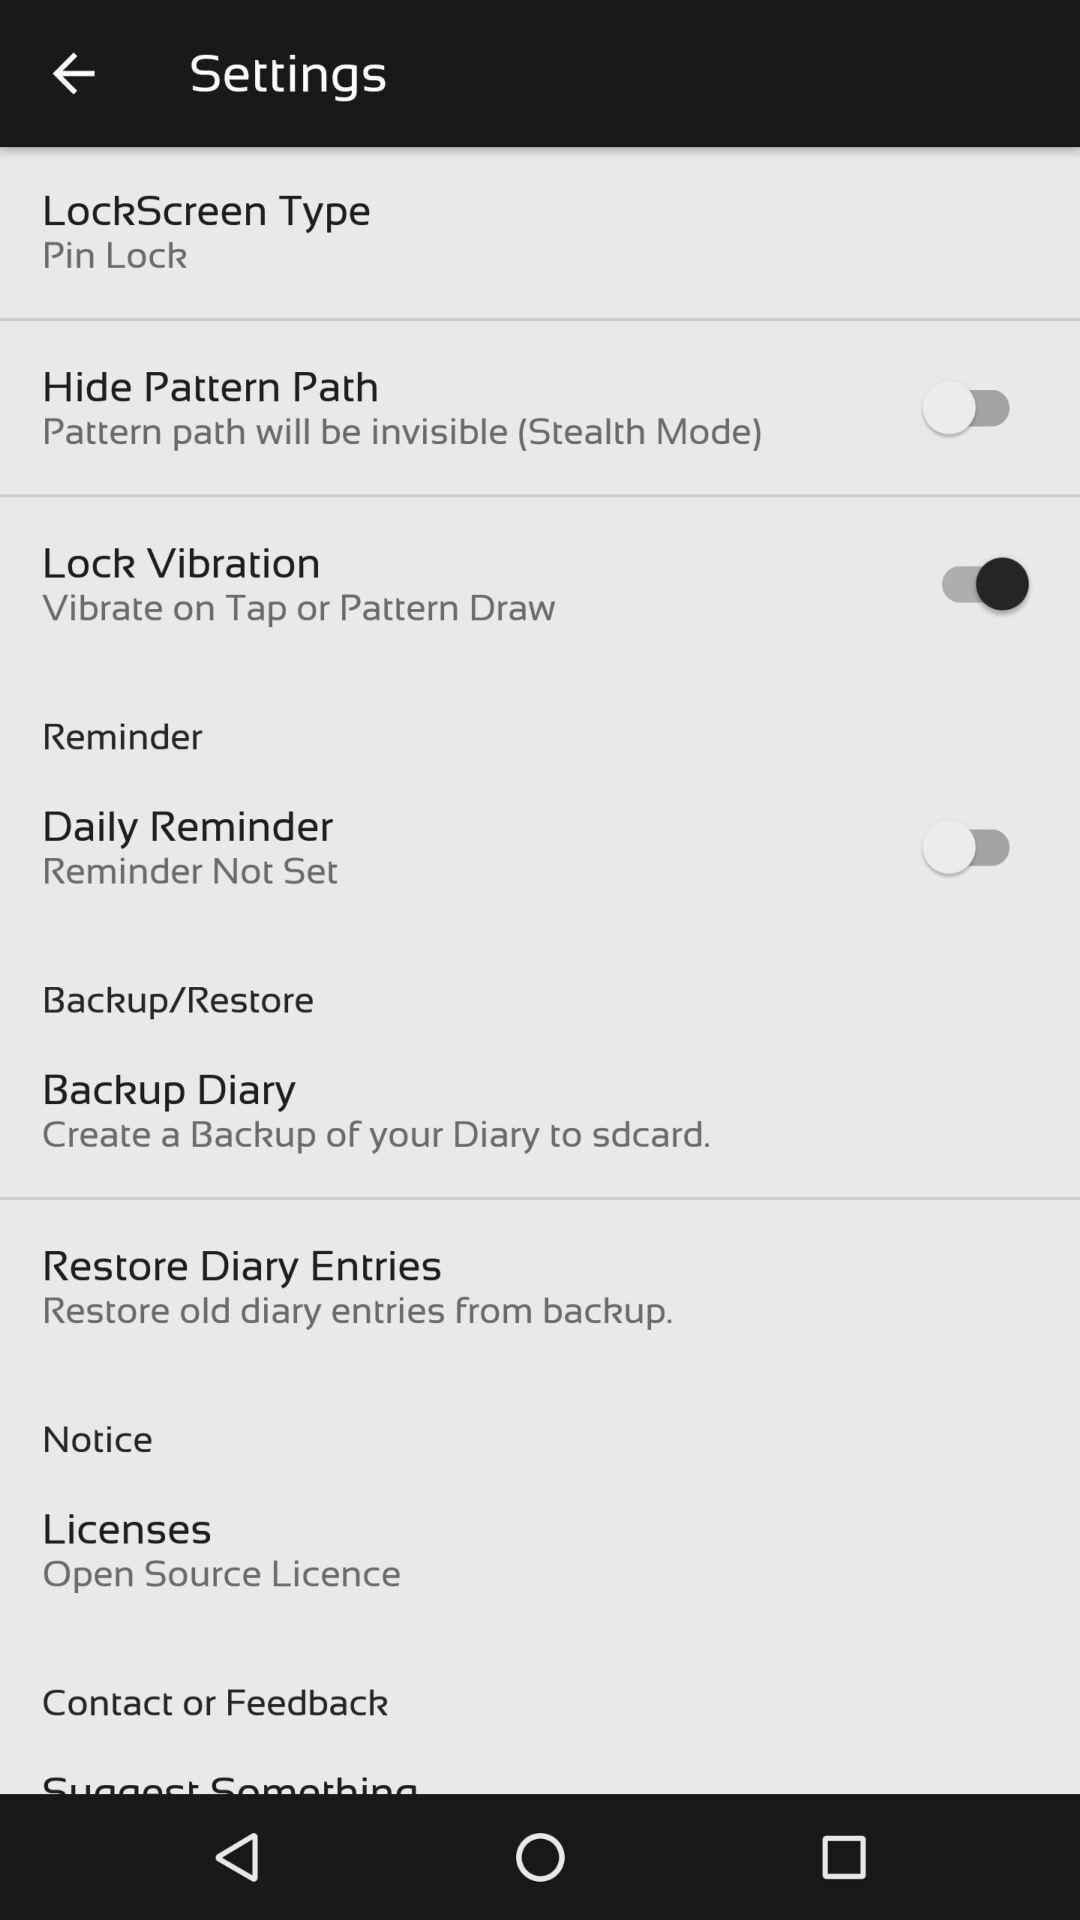What details can you identify in this image? Screen shows settings list. 